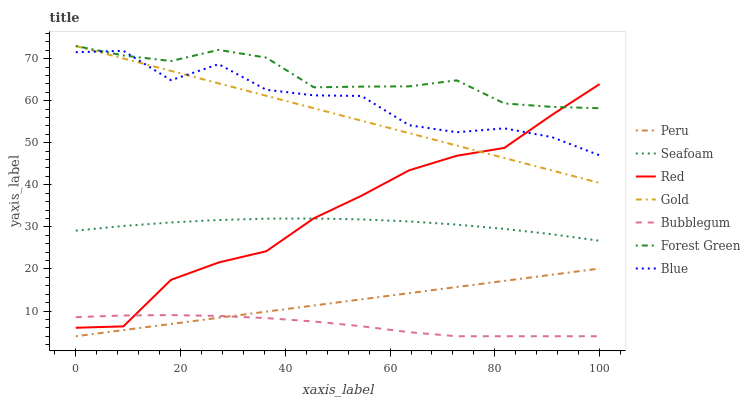Does Bubblegum have the minimum area under the curve?
Answer yes or no. Yes. Does Forest Green have the maximum area under the curve?
Answer yes or no. Yes. Does Gold have the minimum area under the curve?
Answer yes or no. No. Does Gold have the maximum area under the curve?
Answer yes or no. No. Is Peru the smoothest?
Answer yes or no. Yes. Is Blue the roughest?
Answer yes or no. Yes. Is Gold the smoothest?
Answer yes or no. No. Is Gold the roughest?
Answer yes or no. No. Does Bubblegum have the lowest value?
Answer yes or no. Yes. Does Gold have the lowest value?
Answer yes or no. No. Does Forest Green have the highest value?
Answer yes or no. Yes. Does Seafoam have the highest value?
Answer yes or no. No. Is Peru less than Blue?
Answer yes or no. Yes. Is Blue greater than Seafoam?
Answer yes or no. Yes. Does Gold intersect Red?
Answer yes or no. Yes. Is Gold less than Red?
Answer yes or no. No. Is Gold greater than Red?
Answer yes or no. No. Does Peru intersect Blue?
Answer yes or no. No. 